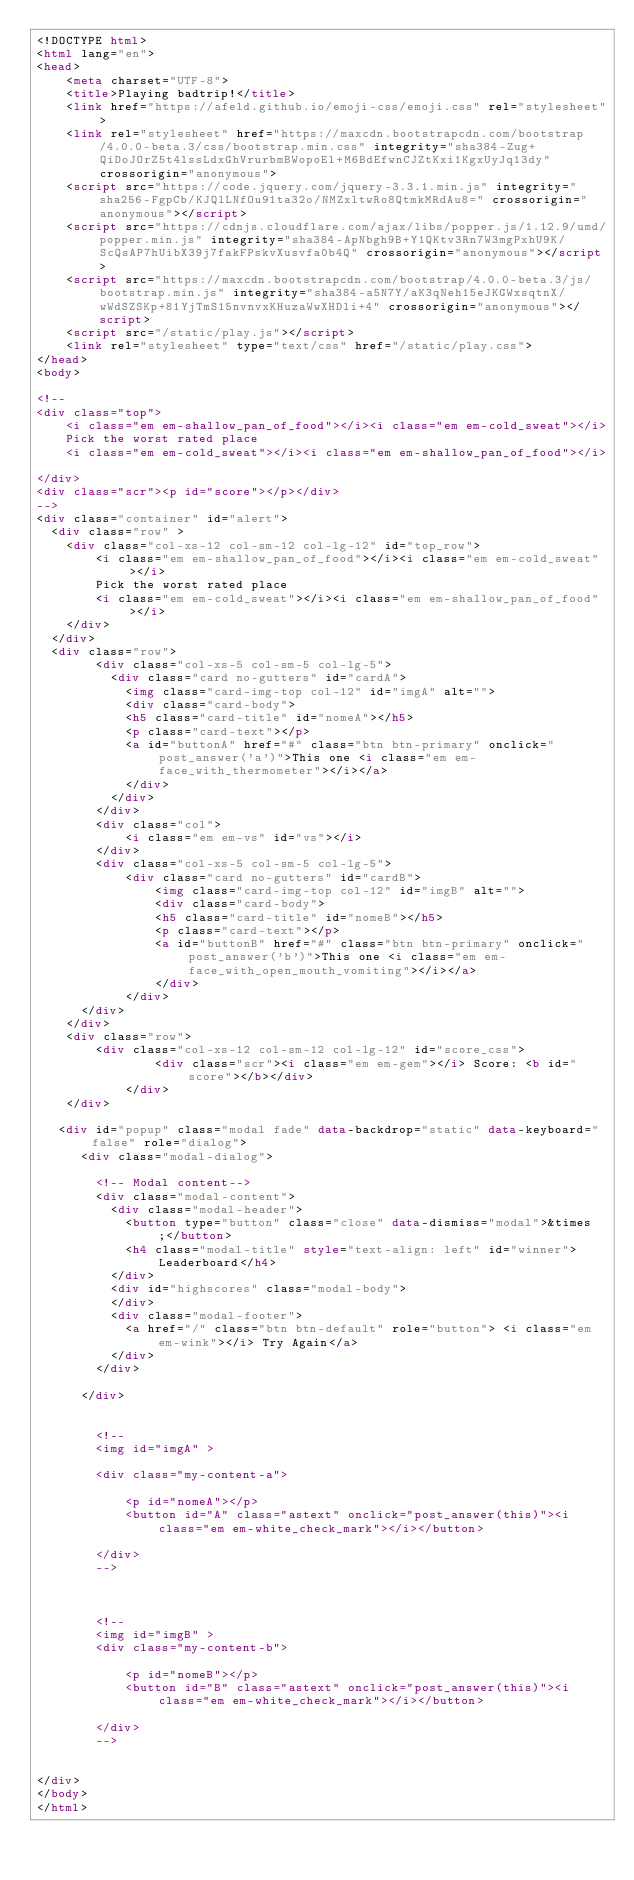Convert code to text. <code><loc_0><loc_0><loc_500><loc_500><_HTML_><!DOCTYPE html>
<html lang="en">
<head>
    <meta charset="UTF-8">
    <title>Playing badtrip!</title>
    <link href="https://afeld.github.io/emoji-css/emoji.css" rel="stylesheet">
    <link rel="stylesheet" href="https://maxcdn.bootstrapcdn.com/bootstrap/4.0.0-beta.3/css/bootstrap.min.css" integrity="sha384-Zug+QiDoJOrZ5t4lssLdxGhVrurbmBWopoEl+M6BdEfwnCJZtKxi1KgxUyJq13dy" crossorigin="anonymous">
    <script src="https://code.jquery.com/jquery-3.3.1.min.js" integrity="sha256-FgpCb/KJQlLNfOu91ta32o/NMZxltwRo8QtmkMRdAu8=" crossorigin="anonymous"></script>
    <script src="https://cdnjs.cloudflare.com/ajax/libs/popper.js/1.12.9/umd/popper.min.js" integrity="sha384-ApNbgh9B+Y1QKtv3Rn7W3mgPxhU9K/ScQsAP7hUibX39j7fakFPskvXusvfa0b4Q" crossorigin="anonymous"></script>
    <script src="https://maxcdn.bootstrapcdn.com/bootstrap/4.0.0-beta.3/js/bootstrap.min.js" integrity="sha384-a5N7Y/aK3qNeh15eJKGWxsqtnX/wWdSZSKp+81YjTmS15nvnvxKHuzaWwXHDli+4" crossorigin="anonymous"></script>
    <script src="/static/play.js"></script>
    <link rel="stylesheet" type="text/css" href="/static/play.css">
</head>
<body>

<!--
<div class="top">
    <i class="em em-shallow_pan_of_food"></i><i class="em em-cold_sweat"></i>
    Pick the worst rated place
    <i class="em em-cold_sweat"></i><i class="em em-shallow_pan_of_food"></i>

</div>
<div class="scr"><p id="score"></p></div>
-->
<div class="container" id="alert">
  <div class="row" >
    <div class="col-xs-12 col-sm-12 col-lg-12" id="top_row">
        <i class="em em-shallow_pan_of_food"></i><i class="em em-cold_sweat"></i>
        Pick the worst rated place
        <i class="em em-cold_sweat"></i><i class="em em-shallow_pan_of_food"></i>
    </div>
  </div>
  <div class="row">
        <div class="col-xs-5 col-sm-5 col-lg-5">
          <div class="card no-gutters" id="cardA">
            <img class="card-img-top col-12" id="imgA" alt="">
            <div class="card-body">
            <h5 class="card-title" id="nomeA"></h5>
            <p class="card-text"></p>
            <a id="buttonA" href="#" class="btn btn-primary" onclick="post_answer('a')">This one <i class="em em-face_with_thermometer"></i></a>
            </div>
          </div>
        </div>
        <div class="col">
            <i class="em em-vs" id="vs"></i>
        </div>
        <div class="col-xs-5 col-sm-5 col-lg-5">
            <div class="card no-gutters" id="cardB">
                <img class="card-img-top col-12" id="imgB" alt="">
                <div class="card-body">
                <h5 class="card-title" id="nomeB"></h5>
                <p class="card-text"></p>
                <a id="buttonB" href="#" class="btn btn-primary" onclick="post_answer('b')">This one <i class="em em-face_with_open_mouth_vomiting"></i></a>
                </div>
            </div>
      </div>
    </div>
    <div class="row">
        <div class="col-xs-12 col-sm-12 col-lg-12" id="score_css">
                <div class="scr"><i class="em em-gem"></i> Score: <b id="score"></b></div>
            </div>
    </div>

   <div id="popup" class="modal fade" data-backdrop="static" data-keyboard="false" role="dialog">
      <div class="modal-dialog">

        <!-- Modal content-->
        <div class="modal-content">
          <div class="modal-header">
            <button type="button" class="close" data-dismiss="modal">&times;</button>
            <h4 class="modal-title" style="text-align: left" id="winner">Leaderboard</h4>
          </div>
          <div id="highscores" class="modal-body">
          </div>
          <div class="modal-footer">
            <a href="/" class="btn btn-default" role="button"> <i class="em em-wink"></i> Try Again</a>
          </div>
        </div>

      </div>


        <!--
        <img id="imgA" >

        <div class="my-content-a">

            <p id="nomeA"></p>
            <button id="A" class="astext" onclick="post_answer(this)"><i class="em em-white_check_mark"></i></button>

        </div>
        -->



        <!--
        <img id="imgB" >
        <div class="my-content-b">

            <p id="nomeB"></p>
            <button id="B" class="astext" onclick="post_answer(this)"><i class="em em-white_check_mark"></i></button>

        </div>
        -->


</div>
</body>
</html></code> 